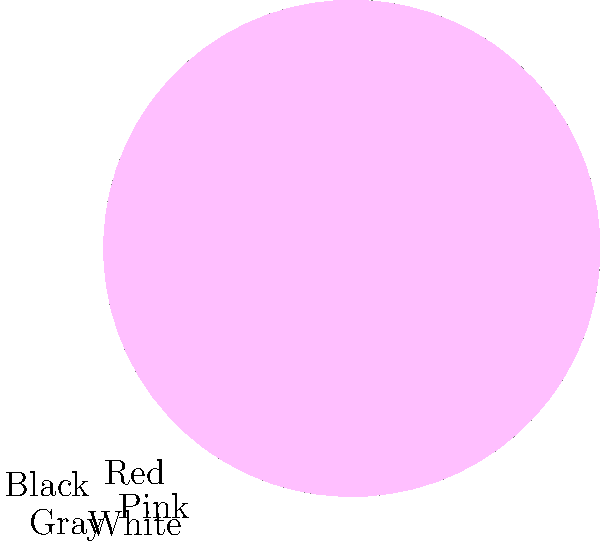In "Pink Floyd: The Wall," directed by Sir Alan Parker, which color dominates the film's visual palette according to the color wheel analysis shown above? To answer this question, we need to analyze the color wheel provided:

1. The color wheel is divided into five sections, each representing a color used in the film.
2. The sizes of the sections indicate the prevalence of each color in the film's visual palette.
3. The colors represented are Red, Black, Gray, White, and Pink.
4. By comparing the sizes of the sections, we can see that Red occupies the largest portion of the wheel.
5. This indicates that Red is the most dominant color in the film's visual palette.

The prevalence of red in "Pink Floyd: The Wall" is significant because:

a) It symbolizes themes of anger, violence, and rebellion present in the film.
b) It aligns with the album's artwork and the band's visual aesthetics.
c) Sir Alan Parker likely used red to create a visually striking and emotionally charged atmosphere.

As an emerging film director and fan of Sir Alan Parker's work, understanding his use of color is crucial for developing your own visual style and storytelling techniques.
Answer: Red 